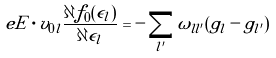<formula> <loc_0><loc_0><loc_500><loc_500>e { E } \cdot { v } _ { 0 l } \frac { \partial f _ { 0 } ( \epsilon _ { l } ) } { \partial { \epsilon _ { l } } } = - \sum _ { l ^ { \prime } } \omega _ { l l ^ { \prime } } ( g _ { l } - g _ { l ^ { \prime } } )</formula> 